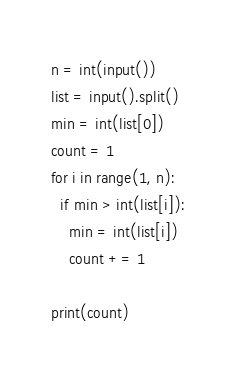<code> <loc_0><loc_0><loc_500><loc_500><_Python_>n = int(input())
list = input().split()
min = int(list[0])
count = 1
for i in range(1, n):
  if min > int(list[i]):
    min = int(list[i])
    count += 1
    
print(count)</code> 